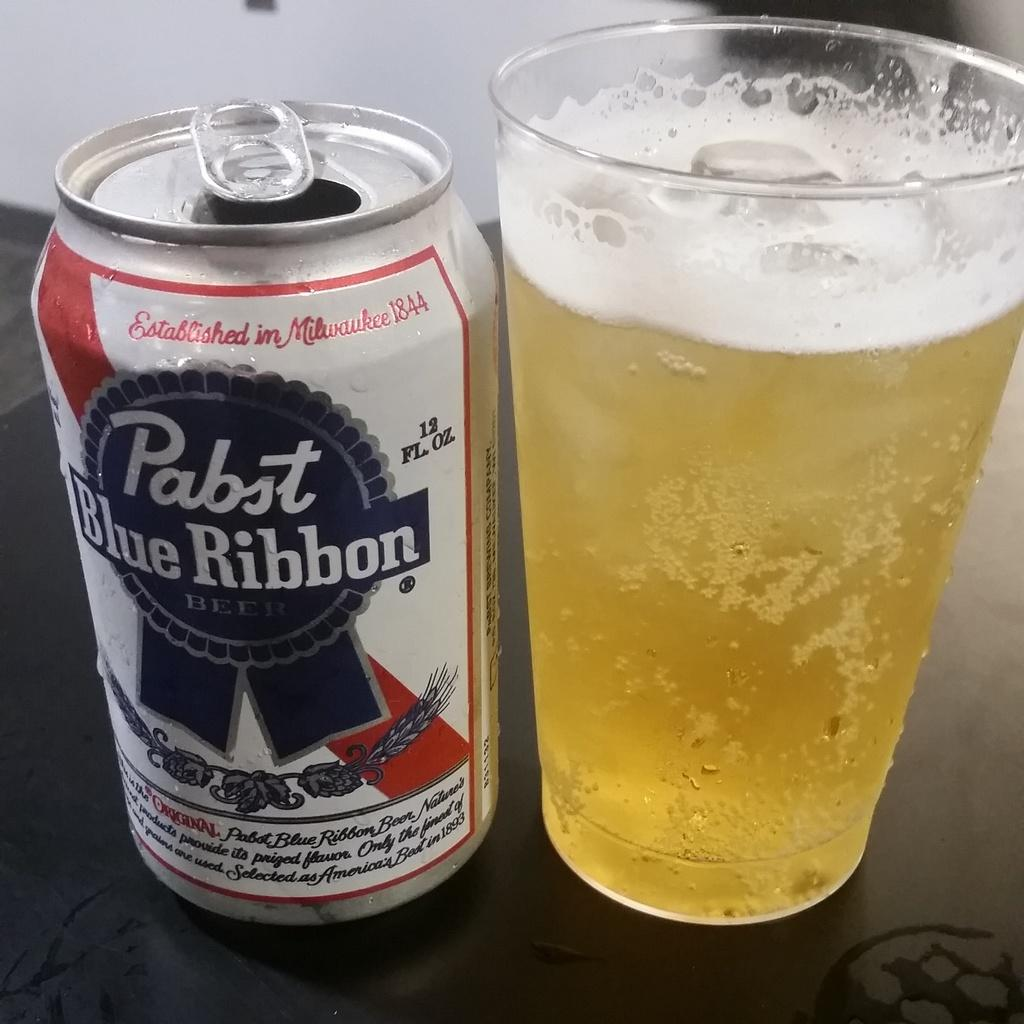What type of beverage container is visible in the image? There is a coke bottle in the image. What else can be seen on the table in the image? There is a glass containing liquid in the image. What is the color of the table in the image? The table is brown in color. What can be seen in the background of the image? There is a wall in the background of the image. What is the color of the wall in the image? The wall is white in color. Can you tell me how many pots are on the table in the image? There are no pots present on the table in the image. Is there a chessboard visible on the table in the image? There is no chessboard visible on the table in the image. 